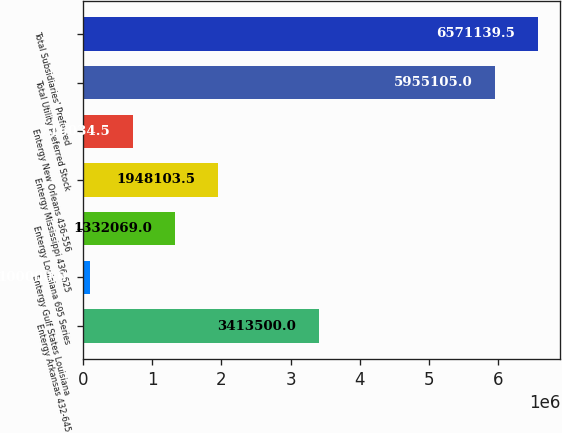Convert chart to OTSL. <chart><loc_0><loc_0><loc_500><loc_500><bar_chart><fcel>Entergy Arkansas 432-645<fcel>Entergy Gulf States Louisiana<fcel>Entergy Louisiana 695 Series<fcel>Entergy Mississippi 436-625<fcel>Entergy New Orleans 436-556<fcel>Total Utility Preferred Stock<fcel>Total Subsidiaries' Preferred<nl><fcel>3.4135e+06<fcel>100000<fcel>1.33207e+06<fcel>1.9481e+06<fcel>716034<fcel>5.9551e+06<fcel>6.57114e+06<nl></chart> 